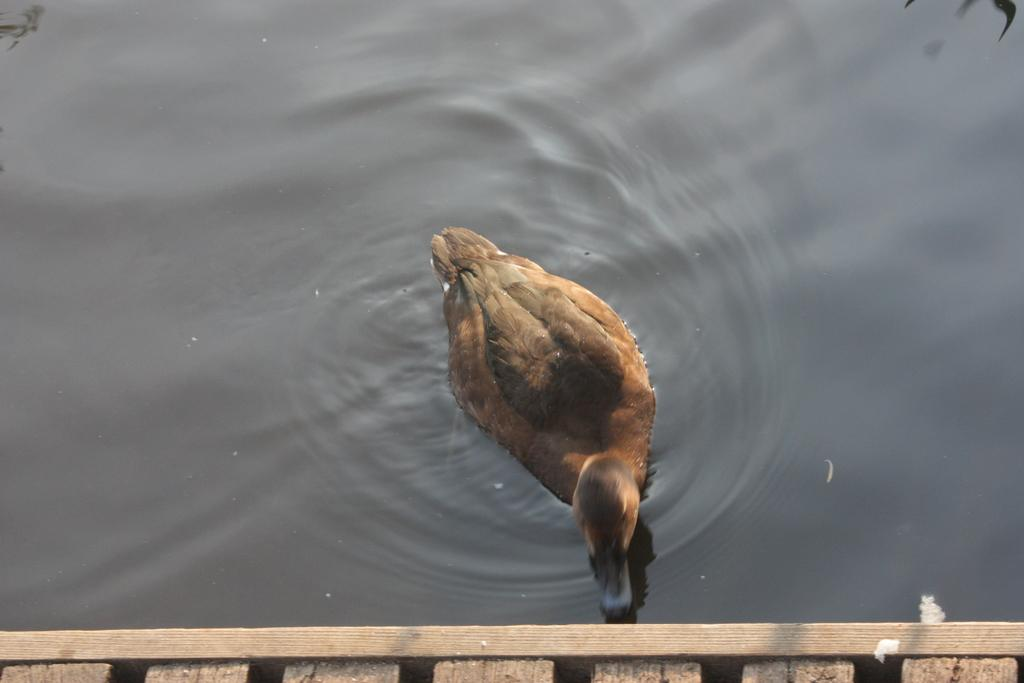What type of animal can be seen in the image? There is a bird on the water in the image. Where is the bird located in the image? The bird is on the water in the image. What type of addition problem can be solved using the bird in the image? There is no addition problem present in the image, as it features a bird on the water. 